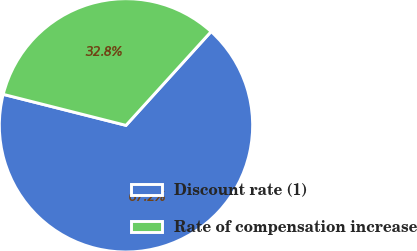Convert chart. <chart><loc_0><loc_0><loc_500><loc_500><pie_chart><fcel>Discount rate (1)<fcel>Rate of compensation increase<nl><fcel>67.21%<fcel>32.79%<nl></chart> 